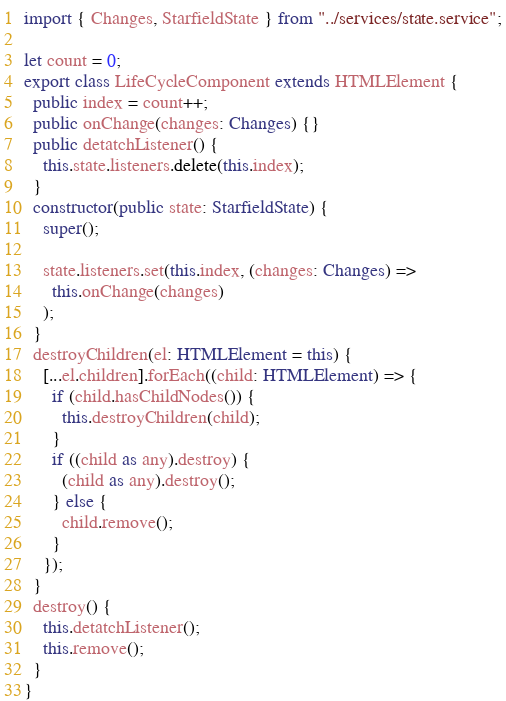Convert code to text. <code><loc_0><loc_0><loc_500><loc_500><_TypeScript_>import { Changes, StarfieldState } from "../services/state.service";

let count = 0;
export class LifeCycleComponent extends HTMLElement {
  public index = count++;
  public onChange(changes: Changes) {}
  public detatchListener() {
    this.state.listeners.delete(this.index);
  }
  constructor(public state: StarfieldState) {
    super();

    state.listeners.set(this.index, (changes: Changes) =>
      this.onChange(changes)
    );
  }
  destroyChildren(el: HTMLElement = this) {
    [...el.children].forEach((child: HTMLElement) => {
      if (child.hasChildNodes()) {
        this.destroyChildren(child);
      }
      if ((child as any).destroy) {
        (child as any).destroy();
      } else {
        child.remove();
      }
    });
  }
  destroy() {
    this.detatchListener();
    this.remove();
  }
}
</code> 